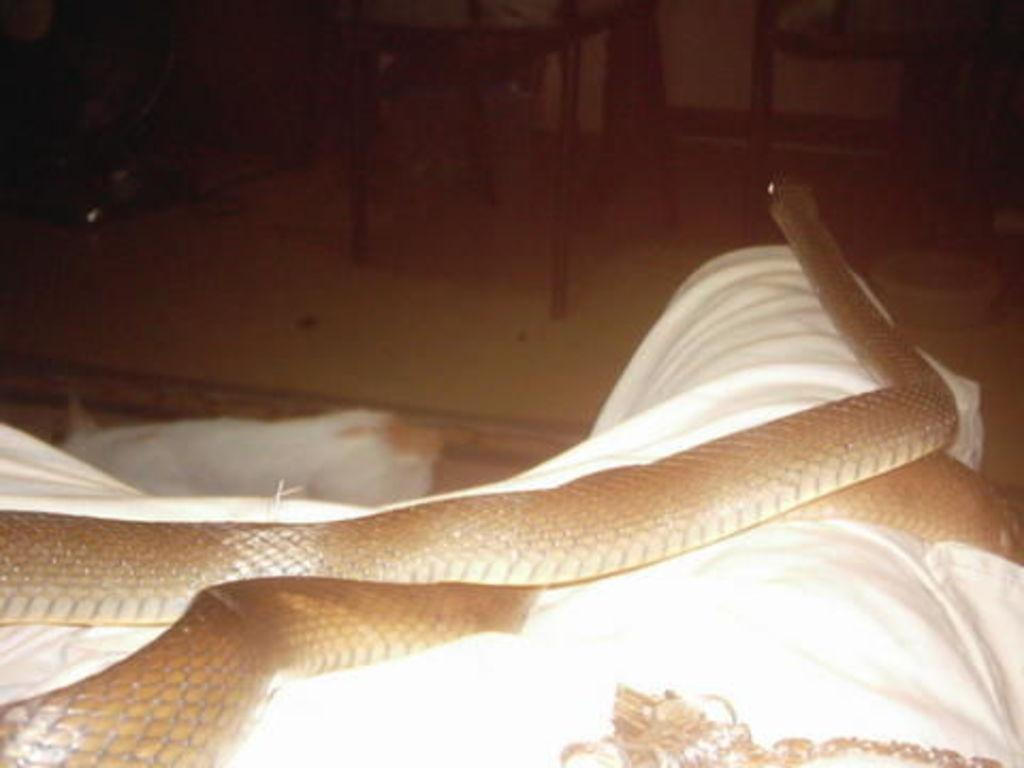Who or what is present in the image? There is a person in the image. What is on the person? There is a snake on the person. What type of competition is taking place in the image? There is no competition present in the image; it only features a person with a snake on them. Is the snake in the image wearing a collar? There is no mention of a collar on the snake in the provided facts, and therefore it cannot be determined from the image. 